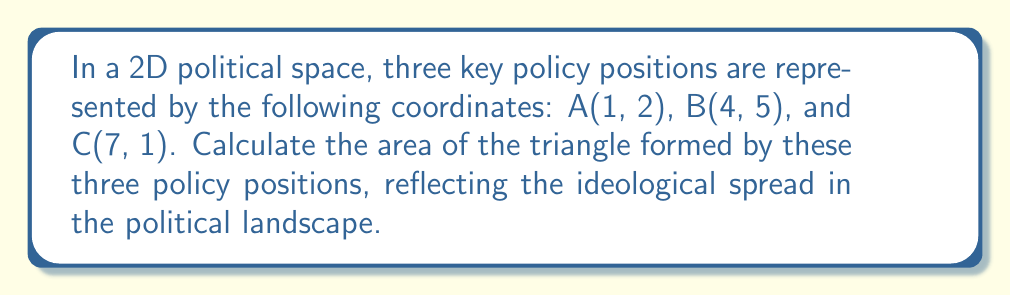Could you help me with this problem? To calculate the area of a triangle given three coordinates, we can use the following steps:

1. Use the formula for the area of a triangle given three vertices:

   $$\text{Area} = \frac{1}{2}|x_1(y_2 - y_3) + x_2(y_3 - y_1) + x_3(y_1 - y_2)|$$

   Where $(x_1, y_1)$, $(x_2, y_2)$, and $(x_3, y_3)$ are the coordinates of the three vertices.

2. Substitute the given coordinates into the formula:
   A(1, 2), B(4, 5), C(7, 1)

   $$\text{Area} = \frac{1}{2}|1(5 - 1) + 4(1 - 2) + 7(2 - 5)|$$

3. Simplify the expression inside the absolute value bars:

   $$\text{Area} = \frac{1}{2}|1(4) + 4(-1) + 7(-3)|$$
   $$\text{Area} = \frac{1}{2}|4 - 4 - 21|$$
   $$\text{Area} = \frac{1}{2}|-21|$$

4. Evaluate the absolute value:

   $$\text{Area} = \frac{1}{2}(21)$$

5. Calculate the final result:

   $$\text{Area} = 10.5$$

The area of the triangle formed by the three policy positions is 10.5 square units in the 2D political space.

[asy]
unitsize(20);
dot((1,2));
dot((4,5));
dot((7,1));
draw((1,2)--(4,5)--(7,1)--cycle);
label("A(1,2)", (1,2), SW);
label("B(4,5)", (4,5), NE);
label("C(7,1)", (7,1), SE);
[/asy]
Answer: 10.5 square units 